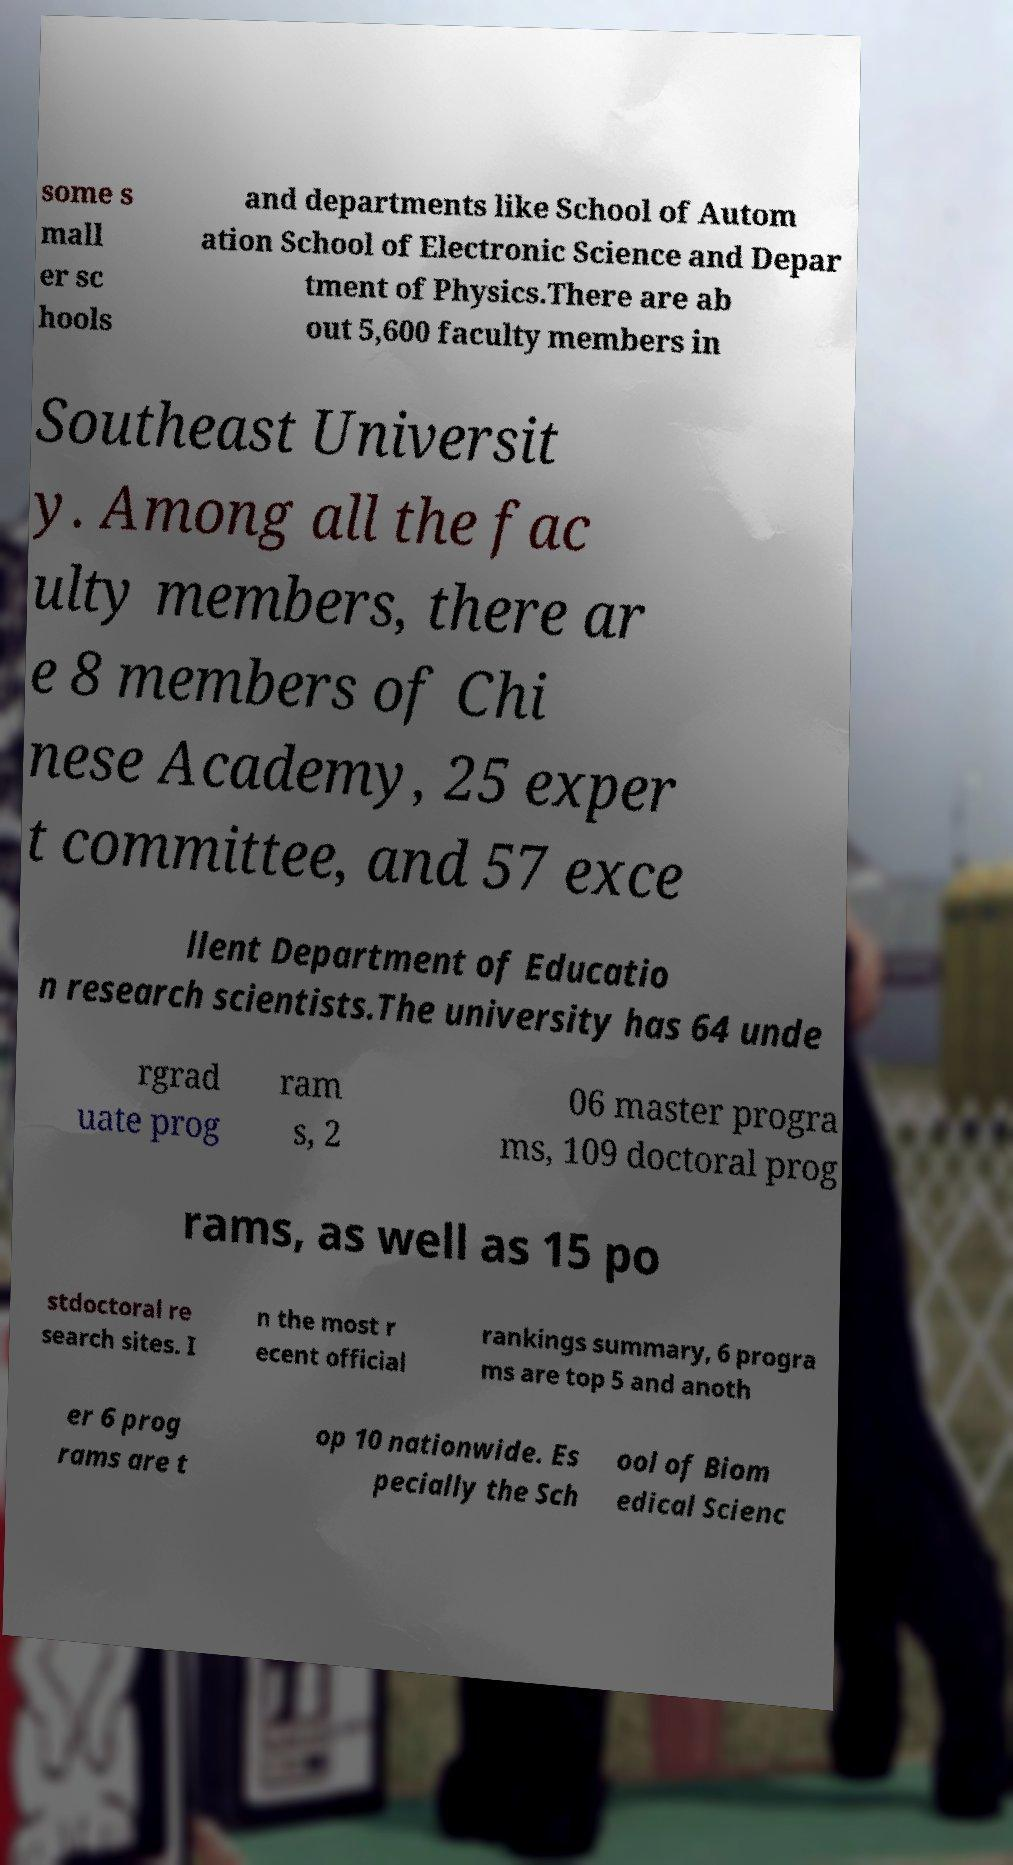What messages or text are displayed in this image? I need them in a readable, typed format. some s mall er sc hools and departments like School of Autom ation School of Electronic Science and Depar tment of Physics.There are ab out 5,600 faculty members in Southeast Universit y. Among all the fac ulty members, there ar e 8 members of Chi nese Academy, 25 exper t committee, and 57 exce llent Department of Educatio n research scientists.The university has 64 unde rgrad uate prog ram s, 2 06 master progra ms, 109 doctoral prog rams, as well as 15 po stdoctoral re search sites. I n the most r ecent official rankings summary, 6 progra ms are top 5 and anoth er 6 prog rams are t op 10 nationwide. Es pecially the Sch ool of Biom edical Scienc 